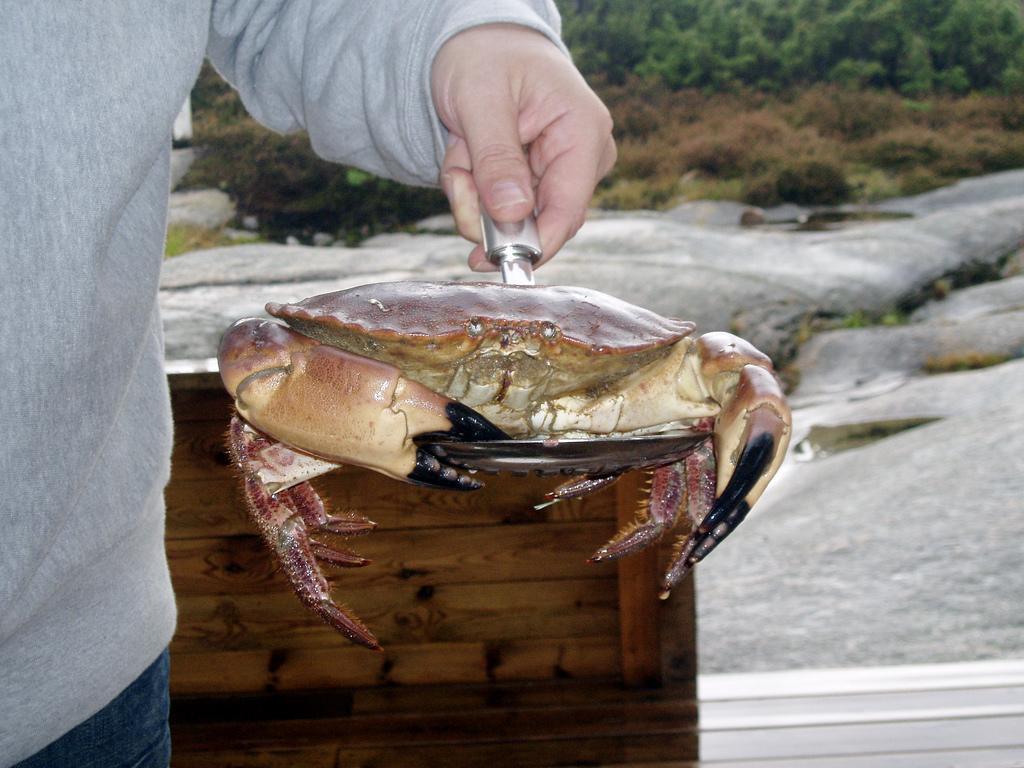How would you summarize this image in a sentence or two? In this image, we can see a person holding a crab. Behind the person, we can see a wooden object. We can also see some rocks, plants and trees. 